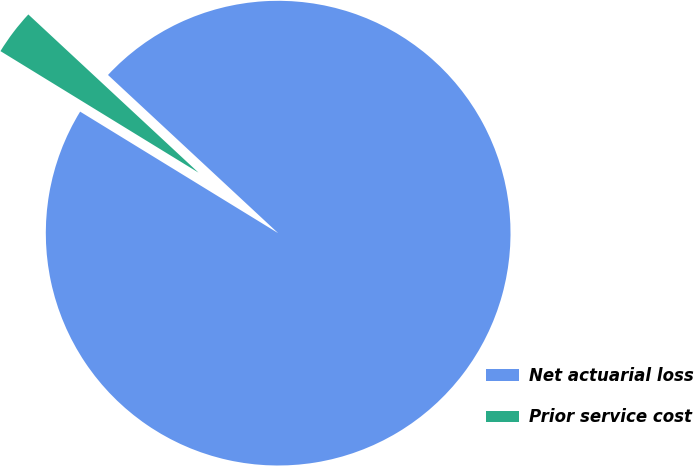Convert chart. <chart><loc_0><loc_0><loc_500><loc_500><pie_chart><fcel>Net actuarial loss<fcel>Prior service cost<nl><fcel>96.84%<fcel>3.16%<nl></chart> 